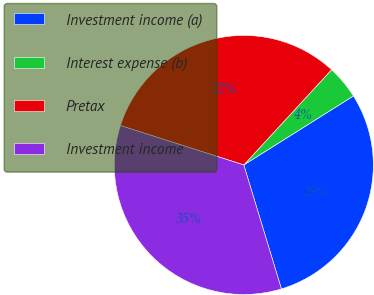Convert chart to OTSL. <chart><loc_0><loc_0><loc_500><loc_500><pie_chart><fcel>Investment income (a)<fcel>Interest expense (b)<fcel>Pretax<fcel>Investment income<nl><fcel>29.25%<fcel>4.21%<fcel>31.93%<fcel>34.61%<nl></chart> 